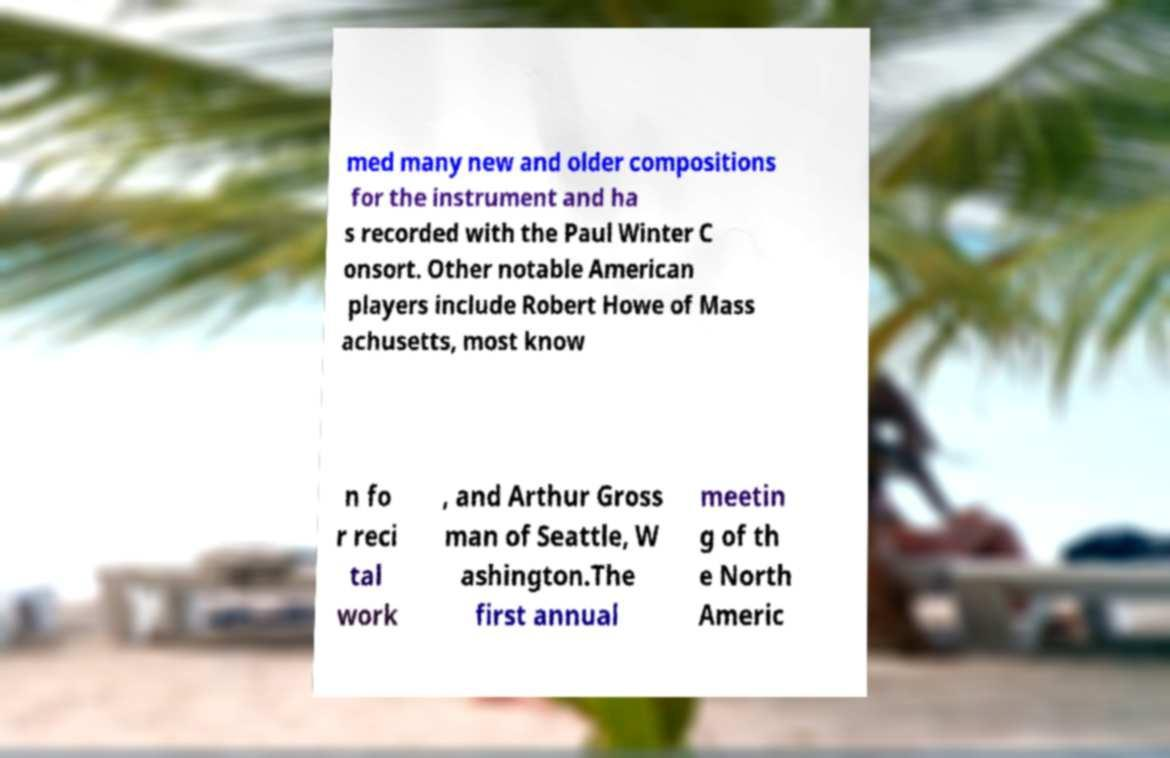Can you accurately transcribe the text from the provided image for me? med many new and older compositions for the instrument and ha s recorded with the Paul Winter C onsort. Other notable American players include Robert Howe of Mass achusetts, most know n fo r reci tal work , and Arthur Gross man of Seattle, W ashington.The first annual meetin g of th e North Americ 